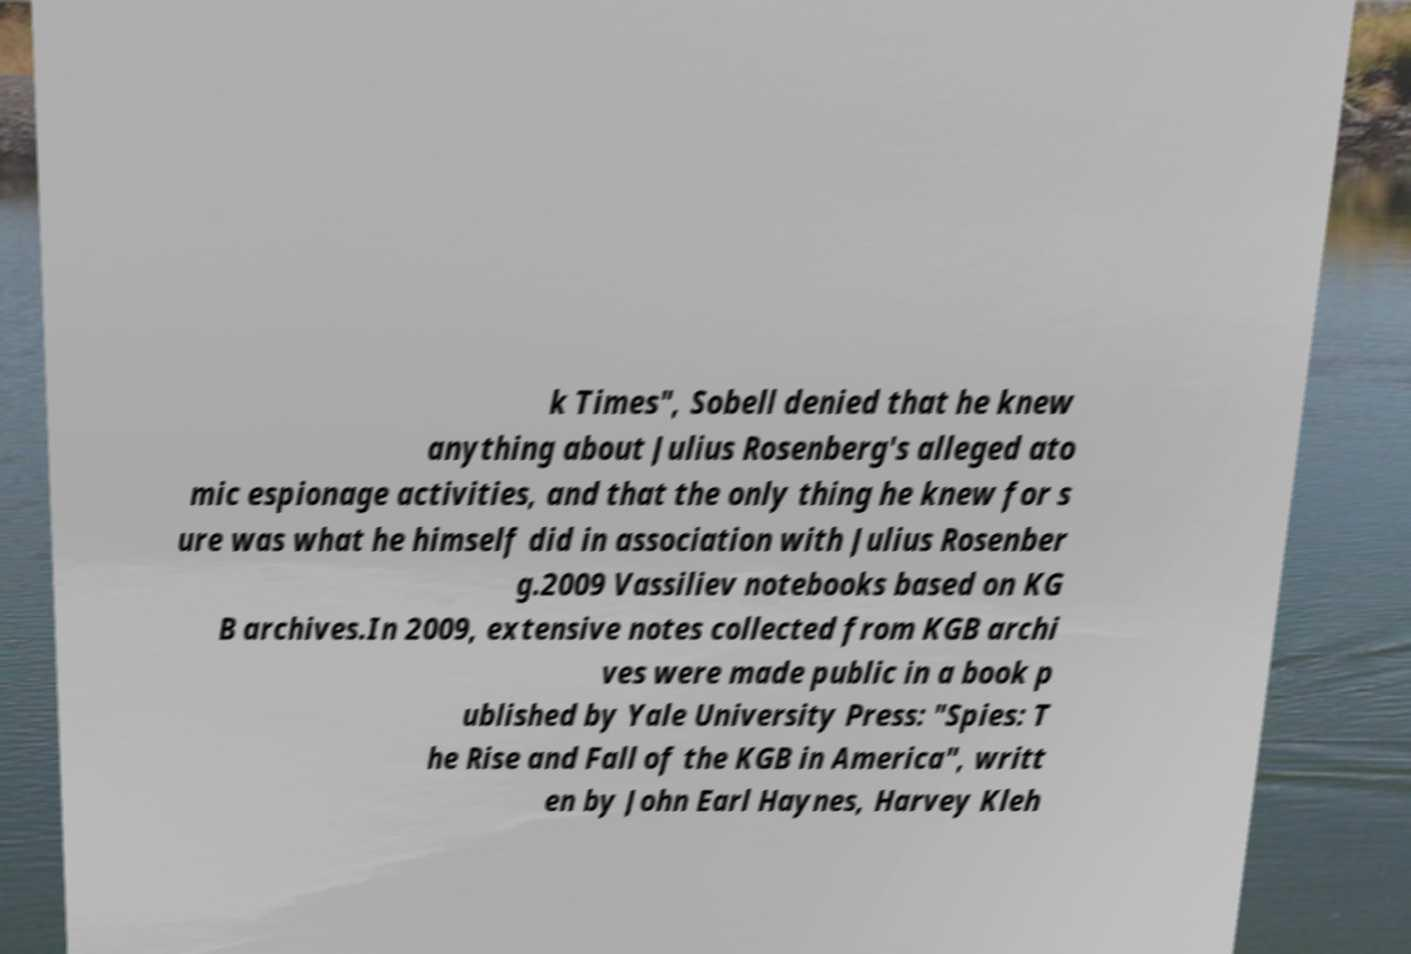There's text embedded in this image that I need extracted. Can you transcribe it verbatim? k Times", Sobell denied that he knew anything about Julius Rosenberg's alleged ato mic espionage activities, and that the only thing he knew for s ure was what he himself did in association with Julius Rosenber g.2009 Vassiliev notebooks based on KG B archives.In 2009, extensive notes collected from KGB archi ves were made public in a book p ublished by Yale University Press: "Spies: T he Rise and Fall of the KGB in America", writt en by John Earl Haynes, Harvey Kleh 